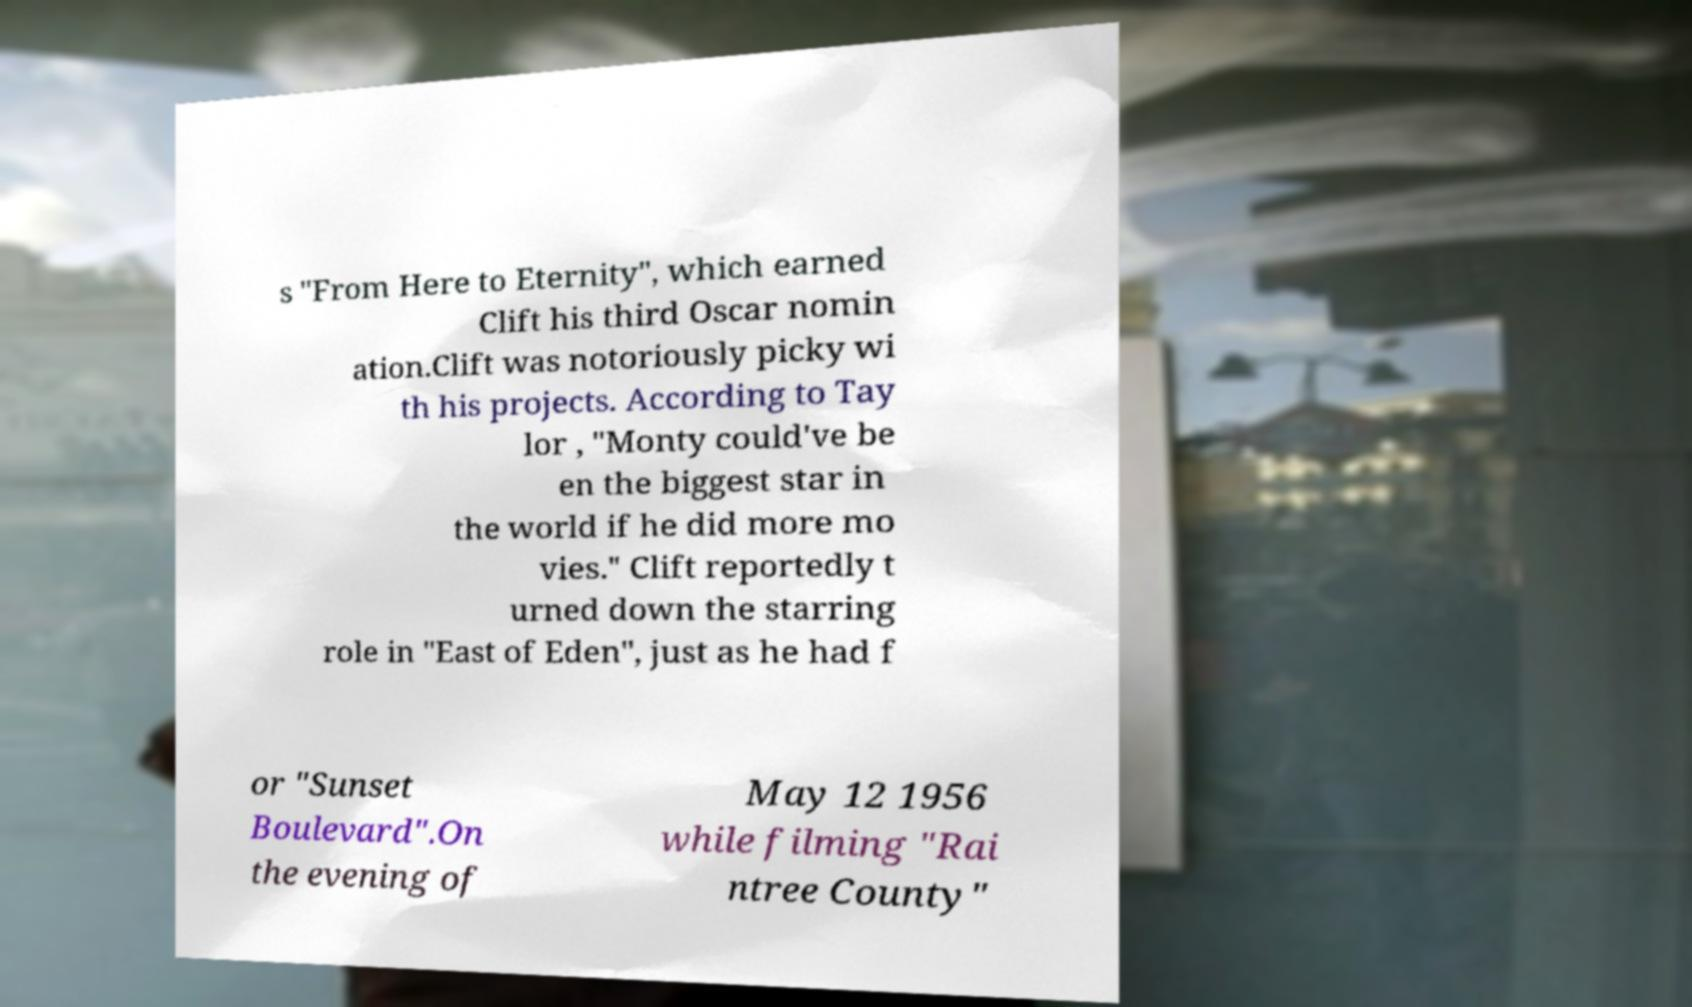For documentation purposes, I need the text within this image transcribed. Could you provide that? s "From Here to Eternity", which earned Clift his third Oscar nomin ation.Clift was notoriously picky wi th his projects. According to Tay lor , "Monty could've be en the biggest star in the world if he did more mo vies." Clift reportedly t urned down the starring role in "East of Eden", just as he had f or "Sunset Boulevard".On the evening of May 12 1956 while filming "Rai ntree County" 